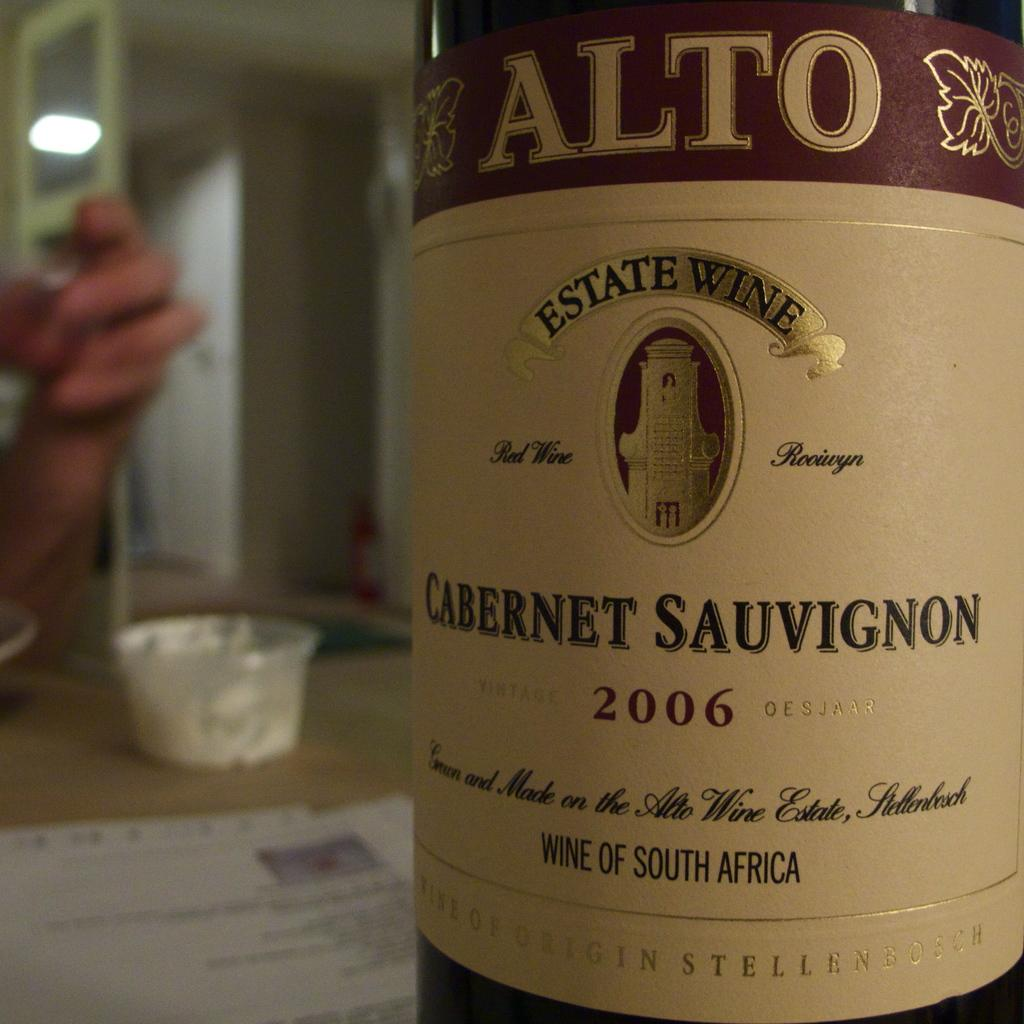What objects can be seen in the image? There is a bottle, a cup, and a paper in the image. What is the color of the surface in the image? The surface is cream-colored. Whose hand is visible in the image? A person's hand is visible in the image. How would you describe the background in the image? The background is blurred. What time of day is it in the image? The time of day cannot be determined from the image, as there are no clues or indicators present. 